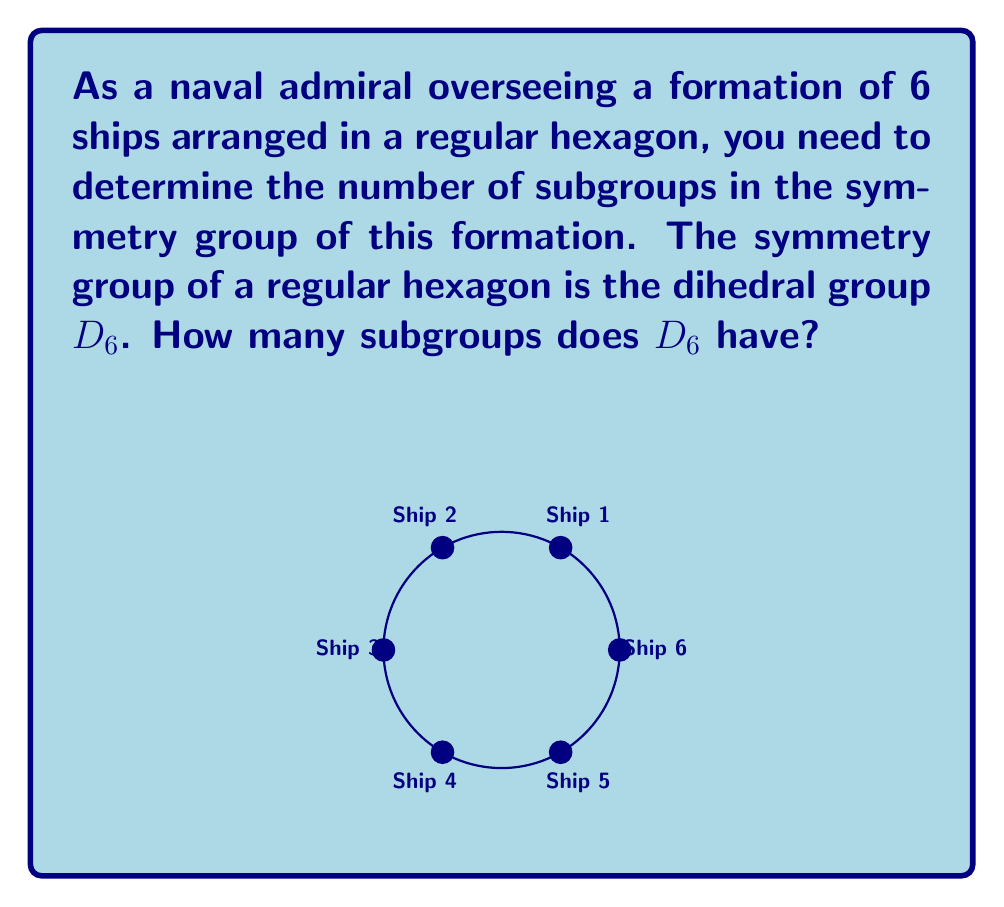Could you help me with this problem? To find the number of subgroups in $D_6$, we'll follow these steps:

1) First, recall that $D_6$ has order 12. Its elements are:
   - 6 rotations (including the identity): $r^0, r^1, r^2, r^3, r^4, r^5$
   - 6 reflections: $s, sr, sr^2, sr^3, sr^4, sr^5$

2) The subgroups of $D_6$ are:
   a) The trivial subgroup: $\{e\}$ (order 1)
   b) 6 subgroups of order 2:
      - 3 generated by reflections: $\langle s \rangle, \langle sr \rangle, \langle sr^2 \rangle$
      - 3 generated by 180° rotations: $\langle r^3 \rangle, \langle sr^3 \rangle, \langle sr^4 \rangle$
   c) 1 subgroup of order 3: $\langle r^2 \rangle$
   d) 4 subgroups of order 4:
      - 3 dihedral subgroups: $\langle r^3, s \rangle, \langle r^3, sr \rangle, \langle r^3, sr^2 \rangle$
      - 1 cyclic subgroup: $\langle r \rangle$
   e) 1 subgroup of order 6: $\langle r^2, s \rangle$
   f) The full group $D_6$ itself (order 12)

3) Counting these subgroups:
   1 + 6 + 1 + 4 + 1 + 1 = 14

Therefore, $D_6$ has 14 subgroups in total.
Answer: 14 